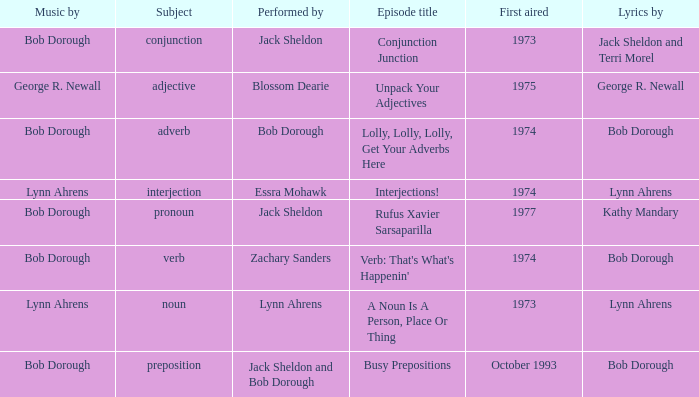When interjection is the subject who are the lyrics by? Lynn Ahrens. 